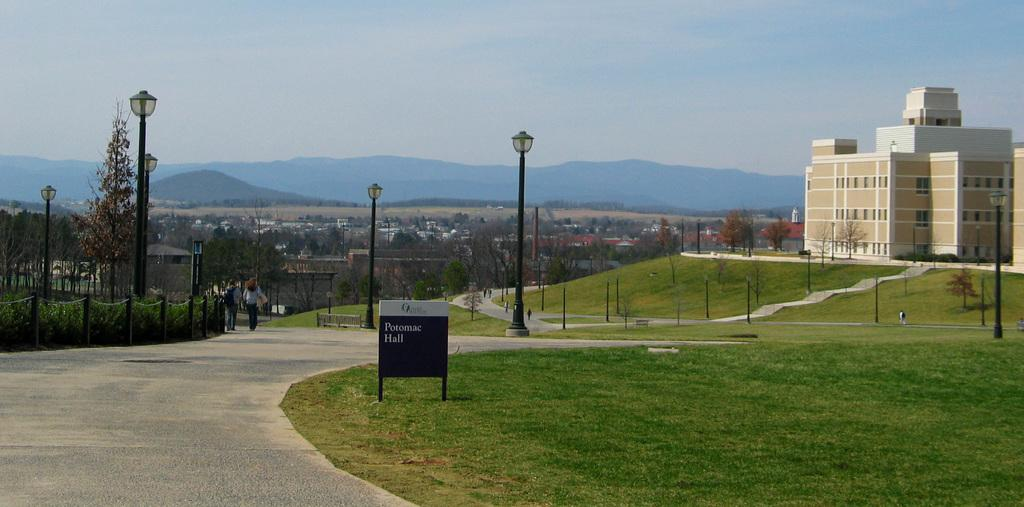What type of structures can be seen in the image? There are buildings with windows in the image. What are the vertical structures that provide light? Light poles are visible in the image. What type of vegetation is present in the image? Plants and trees are visible in the image. What type of barrier can be seen in the image? There is a fence in the image. What type of ground cover is present in the image? Grass is present in the image. What type of surface is used for displaying information or messages? There is a board in the image. What type of natural landform is visible in the image? Mountains are visible in the image. What is visible in the background of the image? The sky is visible in the background of the image. How many bulbs are present in the image? There are no bulbs mentioned or visible in the image. What type of arithmetic problem is being solved by the people in the image? There is no indication of any arithmetic problem being solved in the image. What type of container is being used to collect water in the image? There is no container or water collection activity present in the image. 